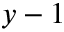<formula> <loc_0><loc_0><loc_500><loc_500>y - 1</formula> 